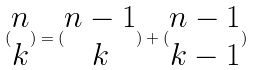<formula> <loc_0><loc_0><loc_500><loc_500>( \begin{matrix} n \\ k \end{matrix} ) = ( \begin{matrix} n - 1 \\ k \end{matrix} ) + ( \begin{matrix} n - 1 \\ k - 1 \end{matrix} )</formula> 